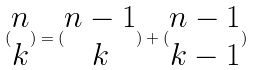<formula> <loc_0><loc_0><loc_500><loc_500>( \begin{matrix} n \\ k \end{matrix} ) = ( \begin{matrix} n - 1 \\ k \end{matrix} ) + ( \begin{matrix} n - 1 \\ k - 1 \end{matrix} )</formula> 